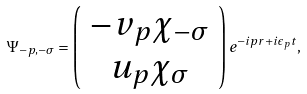Convert formula to latex. <formula><loc_0><loc_0><loc_500><loc_500>\Psi _ { - p , - \sigma } = \left ( \begin{array} { c } - v _ { p } \chi _ { - \sigma } \\ u _ { p } \chi _ { \sigma } \end{array} \right ) e ^ { - i p r + i \epsilon _ { p } t } ,</formula> 